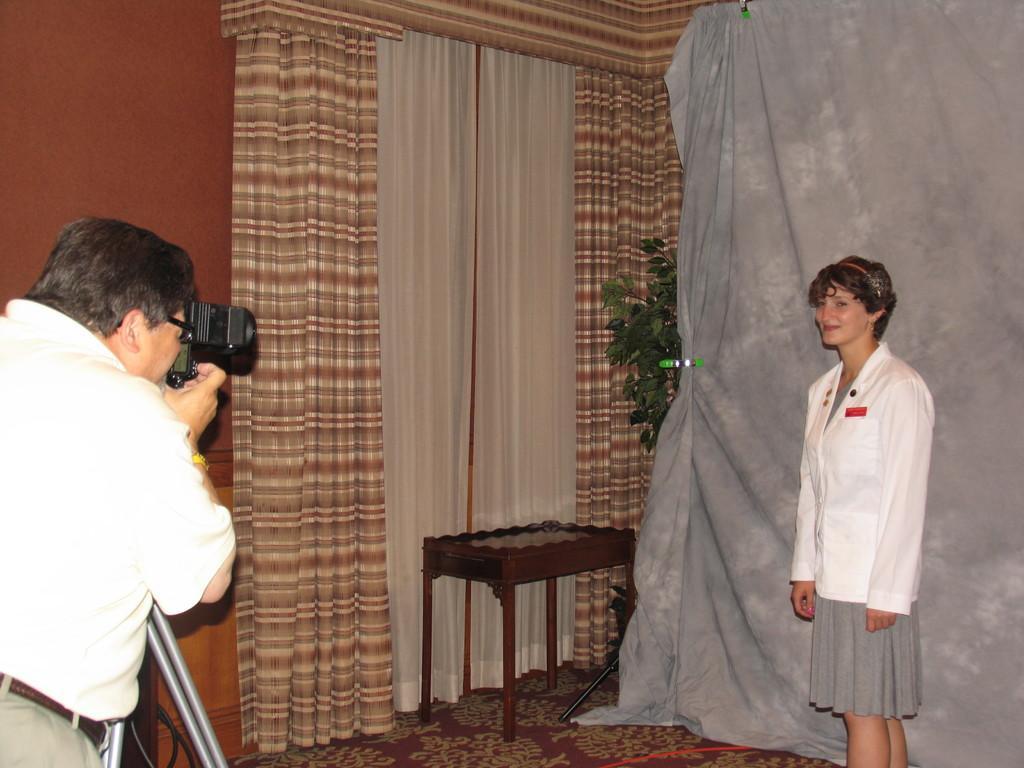How would you summarize this image in a sentence or two? In the bottom left corner of the image a person is standing and holding a camera. In the bottom right corner of the image a woman is standing and smiling. Behind her there is a curtain and there is a plant. In the middle of the image there is a table. Behind the table there is a wall and curtain. 